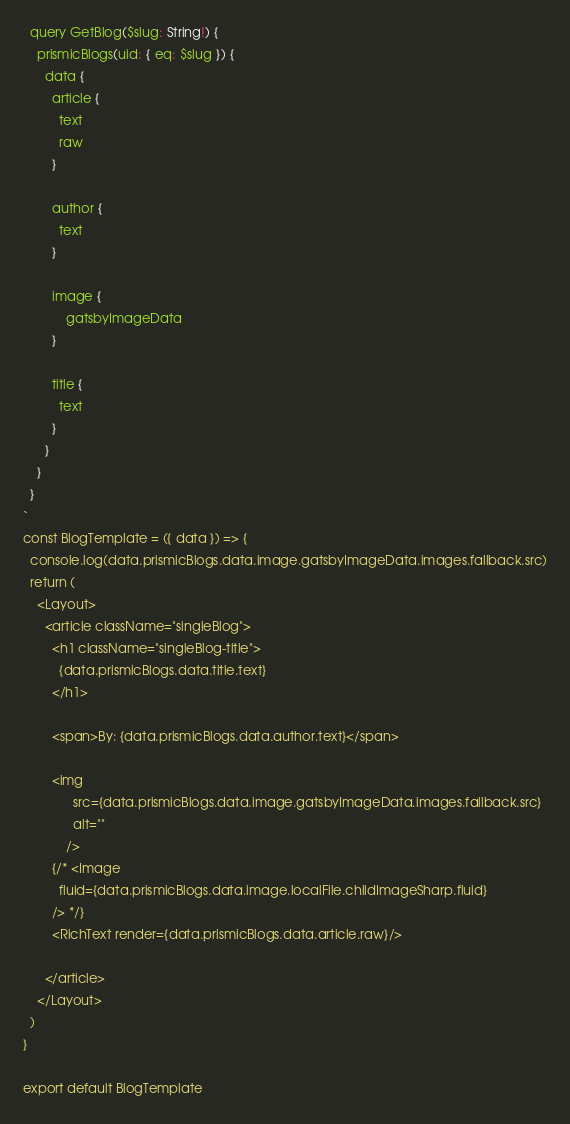<code> <loc_0><loc_0><loc_500><loc_500><_JavaScript_>  query GetBlog($slug: String!) {
    prismicBlogs(uid: { eq: $slug }) {
      data {
        article {
          text
          raw
        }

        author {
          text
        }

        image {
            gatsbyImageData
        }

        title {
          text
        }
      }
    }
  }
`
const BlogTemplate = ({ data }) => {
  console.log(data.prismicBlogs.data.image.gatsbyImageData.images.fallback.src)
  return (
    <Layout>
      <article className="singleBlog">
        <h1 className="singleBlog-title">
          {data.prismicBlogs.data.title.text}
        </h1>

        <span>By: {data.prismicBlogs.data.author.text}</span>
        
        <img
              src={data.prismicBlogs.data.image.gatsbyImageData.images.fallback.src}
              alt=""
            />
        {/* <Image
          fluid={data.prismicBlogs.data.image.localFile.childImageSharp.fluid}
        /> */}
        <RichText render={data.prismicBlogs.data.article.raw}/>
        
      </article>
    </Layout>
  )
}

export default BlogTemplate
</code> 